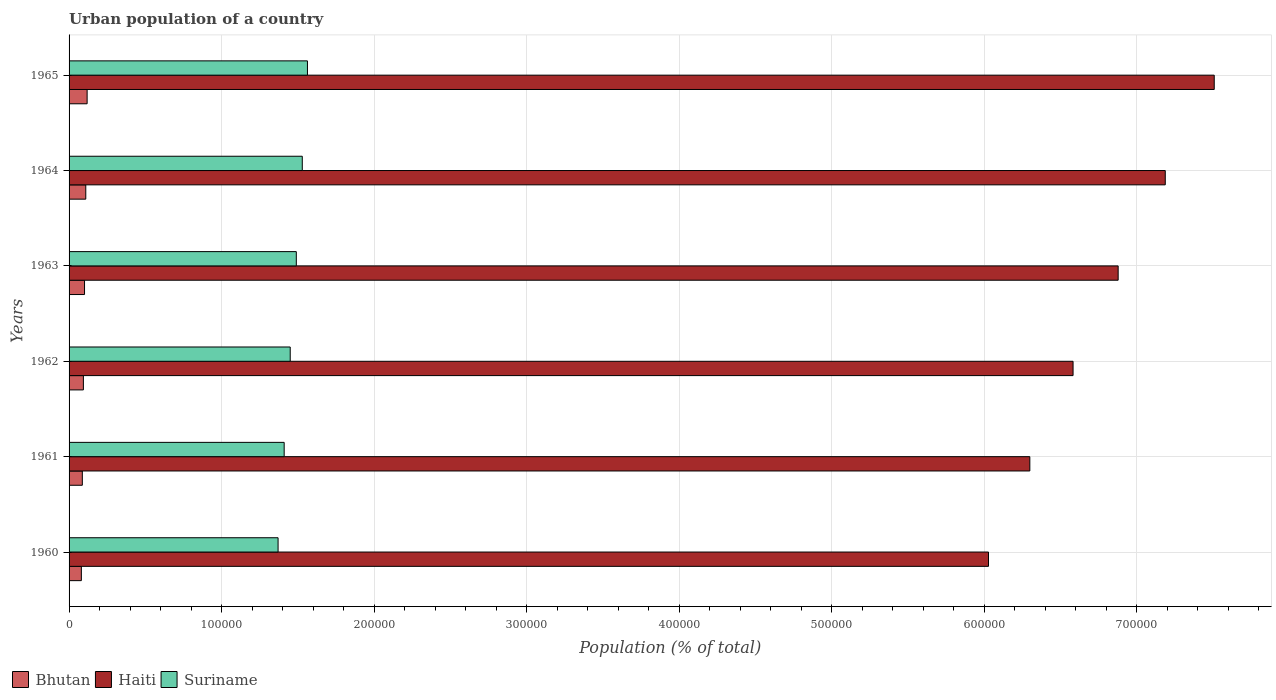How many different coloured bars are there?
Ensure brevity in your answer.  3. Are the number of bars per tick equal to the number of legend labels?
Ensure brevity in your answer.  Yes. How many bars are there on the 1st tick from the bottom?
Make the answer very short. 3. In how many cases, is the number of bars for a given year not equal to the number of legend labels?
Your response must be concise. 0. What is the urban population in Suriname in 1965?
Your answer should be compact. 1.56e+05. Across all years, what is the maximum urban population in Bhutan?
Ensure brevity in your answer.  1.18e+04. Across all years, what is the minimum urban population in Suriname?
Make the answer very short. 1.37e+05. In which year was the urban population in Bhutan maximum?
Offer a terse response. 1965. What is the total urban population in Suriname in the graph?
Ensure brevity in your answer.  8.81e+05. What is the difference between the urban population in Suriname in 1963 and that in 1964?
Give a very brief answer. -3910. What is the difference between the urban population in Suriname in 1965 and the urban population in Bhutan in 1960?
Make the answer very short. 1.48e+05. What is the average urban population in Bhutan per year?
Your response must be concise. 9844.83. In the year 1962, what is the difference between the urban population in Bhutan and urban population in Suriname?
Provide a short and direct response. -1.36e+05. In how many years, is the urban population in Bhutan greater than 760000 %?
Keep it short and to the point. 0. What is the ratio of the urban population in Haiti in 1960 to that in 1962?
Provide a succinct answer. 0.92. Is the difference between the urban population in Bhutan in 1962 and 1964 greater than the difference between the urban population in Suriname in 1962 and 1964?
Ensure brevity in your answer.  Yes. What is the difference between the highest and the second highest urban population in Haiti?
Provide a succinct answer. 3.21e+04. What is the difference between the highest and the lowest urban population in Suriname?
Provide a short and direct response. 1.93e+04. In how many years, is the urban population in Haiti greater than the average urban population in Haiti taken over all years?
Your answer should be compact. 3. What does the 1st bar from the top in 1965 represents?
Keep it short and to the point. Suriname. What does the 2nd bar from the bottom in 1962 represents?
Keep it short and to the point. Haiti. Is it the case that in every year, the sum of the urban population in Haiti and urban population in Suriname is greater than the urban population in Bhutan?
Give a very brief answer. Yes. How many bars are there?
Your response must be concise. 18. Are all the bars in the graph horizontal?
Ensure brevity in your answer.  Yes. Are the values on the major ticks of X-axis written in scientific E-notation?
Your answer should be very brief. No. Does the graph contain any zero values?
Make the answer very short. No. How many legend labels are there?
Offer a terse response. 3. What is the title of the graph?
Provide a succinct answer. Urban population of a country. What is the label or title of the X-axis?
Ensure brevity in your answer.  Population (% of total). What is the Population (% of total) in Bhutan in 1960?
Give a very brief answer. 8059. What is the Population (% of total) in Haiti in 1960?
Your answer should be very brief. 6.03e+05. What is the Population (% of total) of Suriname in 1960?
Offer a terse response. 1.37e+05. What is the Population (% of total) in Bhutan in 1961?
Your answer should be compact. 8695. What is the Population (% of total) of Haiti in 1961?
Ensure brevity in your answer.  6.30e+05. What is the Population (% of total) of Suriname in 1961?
Provide a short and direct response. 1.41e+05. What is the Population (% of total) in Bhutan in 1962?
Your response must be concise. 9386. What is the Population (% of total) in Haiti in 1962?
Your answer should be compact. 6.58e+05. What is the Population (% of total) in Suriname in 1962?
Your answer should be very brief. 1.45e+05. What is the Population (% of total) in Bhutan in 1963?
Your response must be concise. 1.01e+04. What is the Population (% of total) in Haiti in 1963?
Offer a terse response. 6.88e+05. What is the Population (% of total) in Suriname in 1963?
Offer a terse response. 1.49e+05. What is the Population (% of total) in Bhutan in 1964?
Make the answer very short. 1.10e+04. What is the Population (% of total) in Haiti in 1964?
Your answer should be compact. 7.19e+05. What is the Population (% of total) in Suriname in 1964?
Ensure brevity in your answer.  1.53e+05. What is the Population (% of total) of Bhutan in 1965?
Ensure brevity in your answer.  1.18e+04. What is the Population (% of total) in Haiti in 1965?
Your response must be concise. 7.51e+05. What is the Population (% of total) of Suriname in 1965?
Provide a short and direct response. 1.56e+05. Across all years, what is the maximum Population (% of total) of Bhutan?
Offer a very short reply. 1.18e+04. Across all years, what is the maximum Population (% of total) of Haiti?
Provide a short and direct response. 7.51e+05. Across all years, what is the maximum Population (% of total) of Suriname?
Your answer should be compact. 1.56e+05. Across all years, what is the minimum Population (% of total) of Bhutan?
Make the answer very short. 8059. Across all years, what is the minimum Population (% of total) of Haiti?
Offer a terse response. 6.03e+05. Across all years, what is the minimum Population (% of total) of Suriname?
Keep it short and to the point. 1.37e+05. What is the total Population (% of total) of Bhutan in the graph?
Keep it short and to the point. 5.91e+04. What is the total Population (% of total) of Haiti in the graph?
Provide a succinct answer. 4.05e+06. What is the total Population (% of total) in Suriname in the graph?
Make the answer very short. 8.81e+05. What is the difference between the Population (% of total) of Bhutan in 1960 and that in 1961?
Your answer should be very brief. -636. What is the difference between the Population (% of total) in Haiti in 1960 and that in 1961?
Give a very brief answer. -2.71e+04. What is the difference between the Population (% of total) of Suriname in 1960 and that in 1961?
Give a very brief answer. -3994. What is the difference between the Population (% of total) of Bhutan in 1960 and that in 1962?
Provide a short and direct response. -1327. What is the difference between the Population (% of total) of Haiti in 1960 and that in 1962?
Provide a succinct answer. -5.54e+04. What is the difference between the Population (% of total) of Suriname in 1960 and that in 1962?
Make the answer very short. -7960. What is the difference between the Population (% of total) in Bhutan in 1960 and that in 1963?
Keep it short and to the point. -2077. What is the difference between the Population (% of total) of Haiti in 1960 and that in 1963?
Provide a succinct answer. -8.50e+04. What is the difference between the Population (% of total) of Suriname in 1960 and that in 1963?
Your answer should be very brief. -1.20e+04. What is the difference between the Population (% of total) in Bhutan in 1960 and that in 1964?
Offer a terse response. -2893. What is the difference between the Population (% of total) of Haiti in 1960 and that in 1964?
Provide a succinct answer. -1.16e+05. What is the difference between the Population (% of total) in Suriname in 1960 and that in 1964?
Make the answer very short. -1.59e+04. What is the difference between the Population (% of total) in Bhutan in 1960 and that in 1965?
Provide a succinct answer. -3782. What is the difference between the Population (% of total) in Haiti in 1960 and that in 1965?
Offer a terse response. -1.48e+05. What is the difference between the Population (% of total) in Suriname in 1960 and that in 1965?
Give a very brief answer. -1.93e+04. What is the difference between the Population (% of total) in Bhutan in 1961 and that in 1962?
Your response must be concise. -691. What is the difference between the Population (% of total) in Haiti in 1961 and that in 1962?
Your response must be concise. -2.83e+04. What is the difference between the Population (% of total) of Suriname in 1961 and that in 1962?
Offer a very short reply. -3966. What is the difference between the Population (% of total) in Bhutan in 1961 and that in 1963?
Make the answer very short. -1441. What is the difference between the Population (% of total) in Haiti in 1961 and that in 1963?
Offer a terse response. -5.79e+04. What is the difference between the Population (% of total) of Suriname in 1961 and that in 1963?
Make the answer very short. -7964. What is the difference between the Population (% of total) in Bhutan in 1961 and that in 1964?
Keep it short and to the point. -2257. What is the difference between the Population (% of total) of Haiti in 1961 and that in 1964?
Make the answer very short. -8.88e+04. What is the difference between the Population (% of total) of Suriname in 1961 and that in 1964?
Offer a very short reply. -1.19e+04. What is the difference between the Population (% of total) in Bhutan in 1961 and that in 1965?
Provide a succinct answer. -3146. What is the difference between the Population (% of total) in Haiti in 1961 and that in 1965?
Offer a terse response. -1.21e+05. What is the difference between the Population (% of total) in Suriname in 1961 and that in 1965?
Your answer should be compact. -1.53e+04. What is the difference between the Population (% of total) in Bhutan in 1962 and that in 1963?
Provide a short and direct response. -750. What is the difference between the Population (% of total) of Haiti in 1962 and that in 1963?
Keep it short and to the point. -2.96e+04. What is the difference between the Population (% of total) in Suriname in 1962 and that in 1963?
Provide a short and direct response. -3998. What is the difference between the Population (% of total) in Bhutan in 1962 and that in 1964?
Offer a very short reply. -1566. What is the difference between the Population (% of total) in Haiti in 1962 and that in 1964?
Give a very brief answer. -6.05e+04. What is the difference between the Population (% of total) in Suriname in 1962 and that in 1964?
Ensure brevity in your answer.  -7908. What is the difference between the Population (% of total) in Bhutan in 1962 and that in 1965?
Your response must be concise. -2455. What is the difference between the Population (% of total) of Haiti in 1962 and that in 1965?
Provide a short and direct response. -9.26e+04. What is the difference between the Population (% of total) of Suriname in 1962 and that in 1965?
Give a very brief answer. -1.13e+04. What is the difference between the Population (% of total) of Bhutan in 1963 and that in 1964?
Keep it short and to the point. -816. What is the difference between the Population (% of total) in Haiti in 1963 and that in 1964?
Your answer should be compact. -3.09e+04. What is the difference between the Population (% of total) of Suriname in 1963 and that in 1964?
Your response must be concise. -3910. What is the difference between the Population (% of total) of Bhutan in 1963 and that in 1965?
Offer a terse response. -1705. What is the difference between the Population (% of total) in Haiti in 1963 and that in 1965?
Offer a very short reply. -6.30e+04. What is the difference between the Population (% of total) in Suriname in 1963 and that in 1965?
Give a very brief answer. -7308. What is the difference between the Population (% of total) of Bhutan in 1964 and that in 1965?
Offer a very short reply. -889. What is the difference between the Population (% of total) in Haiti in 1964 and that in 1965?
Ensure brevity in your answer.  -3.21e+04. What is the difference between the Population (% of total) of Suriname in 1964 and that in 1965?
Give a very brief answer. -3398. What is the difference between the Population (% of total) of Bhutan in 1960 and the Population (% of total) of Haiti in 1961?
Keep it short and to the point. -6.22e+05. What is the difference between the Population (% of total) in Bhutan in 1960 and the Population (% of total) in Suriname in 1961?
Offer a terse response. -1.33e+05. What is the difference between the Population (% of total) in Haiti in 1960 and the Population (% of total) in Suriname in 1961?
Offer a terse response. 4.62e+05. What is the difference between the Population (% of total) in Bhutan in 1960 and the Population (% of total) in Haiti in 1962?
Your answer should be very brief. -6.50e+05. What is the difference between the Population (% of total) in Bhutan in 1960 and the Population (% of total) in Suriname in 1962?
Ensure brevity in your answer.  -1.37e+05. What is the difference between the Population (% of total) in Haiti in 1960 and the Population (% of total) in Suriname in 1962?
Your response must be concise. 4.58e+05. What is the difference between the Population (% of total) in Bhutan in 1960 and the Population (% of total) in Haiti in 1963?
Provide a succinct answer. -6.80e+05. What is the difference between the Population (% of total) in Bhutan in 1960 and the Population (% of total) in Suriname in 1963?
Offer a terse response. -1.41e+05. What is the difference between the Population (% of total) in Haiti in 1960 and the Population (% of total) in Suriname in 1963?
Make the answer very short. 4.54e+05. What is the difference between the Population (% of total) of Bhutan in 1960 and the Population (% of total) of Haiti in 1964?
Offer a very short reply. -7.11e+05. What is the difference between the Population (% of total) in Bhutan in 1960 and the Population (% of total) in Suriname in 1964?
Provide a short and direct response. -1.45e+05. What is the difference between the Population (% of total) in Haiti in 1960 and the Population (% of total) in Suriname in 1964?
Offer a very short reply. 4.50e+05. What is the difference between the Population (% of total) in Bhutan in 1960 and the Population (% of total) in Haiti in 1965?
Give a very brief answer. -7.43e+05. What is the difference between the Population (% of total) of Bhutan in 1960 and the Population (% of total) of Suriname in 1965?
Your answer should be very brief. -1.48e+05. What is the difference between the Population (% of total) in Haiti in 1960 and the Population (% of total) in Suriname in 1965?
Provide a succinct answer. 4.47e+05. What is the difference between the Population (% of total) in Bhutan in 1961 and the Population (% of total) in Haiti in 1962?
Your answer should be compact. -6.50e+05. What is the difference between the Population (% of total) in Bhutan in 1961 and the Population (% of total) in Suriname in 1962?
Provide a succinct answer. -1.36e+05. What is the difference between the Population (% of total) of Haiti in 1961 and the Population (% of total) of Suriname in 1962?
Your answer should be very brief. 4.85e+05. What is the difference between the Population (% of total) of Bhutan in 1961 and the Population (% of total) of Haiti in 1963?
Make the answer very short. -6.79e+05. What is the difference between the Population (% of total) in Bhutan in 1961 and the Population (% of total) in Suriname in 1963?
Ensure brevity in your answer.  -1.40e+05. What is the difference between the Population (% of total) in Haiti in 1961 and the Population (% of total) in Suriname in 1963?
Give a very brief answer. 4.81e+05. What is the difference between the Population (% of total) of Bhutan in 1961 and the Population (% of total) of Haiti in 1964?
Make the answer very short. -7.10e+05. What is the difference between the Population (% of total) in Bhutan in 1961 and the Population (% of total) in Suriname in 1964?
Make the answer very short. -1.44e+05. What is the difference between the Population (% of total) in Haiti in 1961 and the Population (% of total) in Suriname in 1964?
Offer a very short reply. 4.77e+05. What is the difference between the Population (% of total) in Bhutan in 1961 and the Population (% of total) in Haiti in 1965?
Make the answer very short. -7.42e+05. What is the difference between the Population (% of total) in Bhutan in 1961 and the Population (% of total) in Suriname in 1965?
Offer a very short reply. -1.48e+05. What is the difference between the Population (% of total) in Haiti in 1961 and the Population (% of total) in Suriname in 1965?
Provide a short and direct response. 4.74e+05. What is the difference between the Population (% of total) of Bhutan in 1962 and the Population (% of total) of Haiti in 1963?
Provide a short and direct response. -6.78e+05. What is the difference between the Population (% of total) of Bhutan in 1962 and the Population (% of total) of Suriname in 1963?
Make the answer very short. -1.40e+05. What is the difference between the Population (% of total) in Haiti in 1962 and the Population (% of total) in Suriname in 1963?
Ensure brevity in your answer.  5.09e+05. What is the difference between the Population (% of total) of Bhutan in 1962 and the Population (% of total) of Haiti in 1964?
Keep it short and to the point. -7.09e+05. What is the difference between the Population (% of total) in Bhutan in 1962 and the Population (% of total) in Suriname in 1964?
Keep it short and to the point. -1.44e+05. What is the difference between the Population (% of total) of Haiti in 1962 and the Population (% of total) of Suriname in 1964?
Keep it short and to the point. 5.05e+05. What is the difference between the Population (% of total) in Bhutan in 1962 and the Population (% of total) in Haiti in 1965?
Keep it short and to the point. -7.41e+05. What is the difference between the Population (% of total) of Bhutan in 1962 and the Population (% of total) of Suriname in 1965?
Offer a very short reply. -1.47e+05. What is the difference between the Population (% of total) in Haiti in 1962 and the Population (% of total) in Suriname in 1965?
Ensure brevity in your answer.  5.02e+05. What is the difference between the Population (% of total) of Bhutan in 1963 and the Population (% of total) of Haiti in 1964?
Give a very brief answer. -7.09e+05. What is the difference between the Population (% of total) in Bhutan in 1963 and the Population (% of total) in Suriname in 1964?
Make the answer very short. -1.43e+05. What is the difference between the Population (% of total) of Haiti in 1963 and the Population (% of total) of Suriname in 1964?
Provide a succinct answer. 5.35e+05. What is the difference between the Population (% of total) of Bhutan in 1963 and the Population (% of total) of Haiti in 1965?
Your answer should be very brief. -7.41e+05. What is the difference between the Population (% of total) of Bhutan in 1963 and the Population (% of total) of Suriname in 1965?
Keep it short and to the point. -1.46e+05. What is the difference between the Population (% of total) of Haiti in 1963 and the Population (% of total) of Suriname in 1965?
Your response must be concise. 5.32e+05. What is the difference between the Population (% of total) in Bhutan in 1964 and the Population (% of total) in Haiti in 1965?
Your response must be concise. -7.40e+05. What is the difference between the Population (% of total) in Bhutan in 1964 and the Population (% of total) in Suriname in 1965?
Offer a very short reply. -1.45e+05. What is the difference between the Population (% of total) in Haiti in 1964 and the Population (% of total) in Suriname in 1965?
Give a very brief answer. 5.62e+05. What is the average Population (% of total) of Bhutan per year?
Your answer should be very brief. 9844.83. What is the average Population (% of total) of Haiti per year?
Ensure brevity in your answer.  6.75e+05. What is the average Population (% of total) in Suriname per year?
Make the answer very short. 1.47e+05. In the year 1960, what is the difference between the Population (% of total) of Bhutan and Population (% of total) of Haiti?
Provide a succinct answer. -5.95e+05. In the year 1960, what is the difference between the Population (% of total) of Bhutan and Population (% of total) of Suriname?
Your answer should be very brief. -1.29e+05. In the year 1960, what is the difference between the Population (% of total) of Haiti and Population (% of total) of Suriname?
Offer a very short reply. 4.66e+05. In the year 1961, what is the difference between the Population (% of total) in Bhutan and Population (% of total) in Haiti?
Your answer should be very brief. -6.21e+05. In the year 1961, what is the difference between the Population (% of total) in Bhutan and Population (% of total) in Suriname?
Your answer should be very brief. -1.32e+05. In the year 1961, what is the difference between the Population (% of total) of Haiti and Population (% of total) of Suriname?
Give a very brief answer. 4.89e+05. In the year 1962, what is the difference between the Population (% of total) in Bhutan and Population (% of total) in Haiti?
Your response must be concise. -6.49e+05. In the year 1962, what is the difference between the Population (% of total) of Bhutan and Population (% of total) of Suriname?
Your answer should be compact. -1.36e+05. In the year 1962, what is the difference between the Population (% of total) in Haiti and Population (% of total) in Suriname?
Provide a succinct answer. 5.13e+05. In the year 1963, what is the difference between the Population (% of total) of Bhutan and Population (% of total) of Haiti?
Your answer should be very brief. -6.78e+05. In the year 1963, what is the difference between the Population (% of total) of Bhutan and Population (% of total) of Suriname?
Keep it short and to the point. -1.39e+05. In the year 1963, what is the difference between the Population (% of total) in Haiti and Population (% of total) in Suriname?
Give a very brief answer. 5.39e+05. In the year 1964, what is the difference between the Population (% of total) of Bhutan and Population (% of total) of Haiti?
Keep it short and to the point. -7.08e+05. In the year 1964, what is the difference between the Population (% of total) in Bhutan and Population (% of total) in Suriname?
Ensure brevity in your answer.  -1.42e+05. In the year 1964, what is the difference between the Population (% of total) of Haiti and Population (% of total) of Suriname?
Your answer should be compact. 5.66e+05. In the year 1965, what is the difference between the Population (% of total) of Bhutan and Population (% of total) of Haiti?
Offer a very short reply. -7.39e+05. In the year 1965, what is the difference between the Population (% of total) in Bhutan and Population (% of total) in Suriname?
Your response must be concise. -1.44e+05. In the year 1965, what is the difference between the Population (% of total) of Haiti and Population (% of total) of Suriname?
Offer a terse response. 5.95e+05. What is the ratio of the Population (% of total) in Bhutan in 1960 to that in 1961?
Your answer should be very brief. 0.93. What is the ratio of the Population (% of total) of Suriname in 1960 to that in 1961?
Your answer should be compact. 0.97. What is the ratio of the Population (% of total) in Bhutan in 1960 to that in 1962?
Keep it short and to the point. 0.86. What is the ratio of the Population (% of total) of Haiti in 1960 to that in 1962?
Offer a terse response. 0.92. What is the ratio of the Population (% of total) in Suriname in 1960 to that in 1962?
Your answer should be compact. 0.95. What is the ratio of the Population (% of total) of Bhutan in 1960 to that in 1963?
Offer a terse response. 0.8. What is the ratio of the Population (% of total) of Haiti in 1960 to that in 1963?
Make the answer very short. 0.88. What is the ratio of the Population (% of total) of Suriname in 1960 to that in 1963?
Offer a terse response. 0.92. What is the ratio of the Population (% of total) of Bhutan in 1960 to that in 1964?
Your answer should be compact. 0.74. What is the ratio of the Population (% of total) of Haiti in 1960 to that in 1964?
Make the answer very short. 0.84. What is the ratio of the Population (% of total) in Suriname in 1960 to that in 1964?
Make the answer very short. 0.9. What is the ratio of the Population (% of total) in Bhutan in 1960 to that in 1965?
Make the answer very short. 0.68. What is the ratio of the Population (% of total) in Haiti in 1960 to that in 1965?
Ensure brevity in your answer.  0.8. What is the ratio of the Population (% of total) of Suriname in 1960 to that in 1965?
Provide a succinct answer. 0.88. What is the ratio of the Population (% of total) in Bhutan in 1961 to that in 1962?
Provide a short and direct response. 0.93. What is the ratio of the Population (% of total) in Haiti in 1961 to that in 1962?
Your response must be concise. 0.96. What is the ratio of the Population (% of total) in Suriname in 1961 to that in 1962?
Your answer should be very brief. 0.97. What is the ratio of the Population (% of total) in Bhutan in 1961 to that in 1963?
Keep it short and to the point. 0.86. What is the ratio of the Population (% of total) of Haiti in 1961 to that in 1963?
Make the answer very short. 0.92. What is the ratio of the Population (% of total) of Suriname in 1961 to that in 1963?
Offer a terse response. 0.95. What is the ratio of the Population (% of total) of Bhutan in 1961 to that in 1964?
Offer a terse response. 0.79. What is the ratio of the Population (% of total) in Haiti in 1961 to that in 1964?
Offer a very short reply. 0.88. What is the ratio of the Population (% of total) of Suriname in 1961 to that in 1964?
Give a very brief answer. 0.92. What is the ratio of the Population (% of total) of Bhutan in 1961 to that in 1965?
Offer a very short reply. 0.73. What is the ratio of the Population (% of total) in Haiti in 1961 to that in 1965?
Offer a terse response. 0.84. What is the ratio of the Population (% of total) in Suriname in 1961 to that in 1965?
Provide a short and direct response. 0.9. What is the ratio of the Population (% of total) of Bhutan in 1962 to that in 1963?
Make the answer very short. 0.93. What is the ratio of the Population (% of total) in Suriname in 1962 to that in 1963?
Your response must be concise. 0.97. What is the ratio of the Population (% of total) in Bhutan in 1962 to that in 1964?
Make the answer very short. 0.86. What is the ratio of the Population (% of total) in Haiti in 1962 to that in 1964?
Make the answer very short. 0.92. What is the ratio of the Population (% of total) in Suriname in 1962 to that in 1964?
Make the answer very short. 0.95. What is the ratio of the Population (% of total) in Bhutan in 1962 to that in 1965?
Make the answer very short. 0.79. What is the ratio of the Population (% of total) of Haiti in 1962 to that in 1965?
Offer a very short reply. 0.88. What is the ratio of the Population (% of total) in Suriname in 1962 to that in 1965?
Make the answer very short. 0.93. What is the ratio of the Population (% of total) of Bhutan in 1963 to that in 1964?
Give a very brief answer. 0.93. What is the ratio of the Population (% of total) of Suriname in 1963 to that in 1964?
Give a very brief answer. 0.97. What is the ratio of the Population (% of total) of Bhutan in 1963 to that in 1965?
Your answer should be very brief. 0.86. What is the ratio of the Population (% of total) in Haiti in 1963 to that in 1965?
Give a very brief answer. 0.92. What is the ratio of the Population (% of total) in Suriname in 1963 to that in 1965?
Keep it short and to the point. 0.95. What is the ratio of the Population (% of total) of Bhutan in 1964 to that in 1965?
Make the answer very short. 0.92. What is the ratio of the Population (% of total) of Haiti in 1964 to that in 1965?
Offer a very short reply. 0.96. What is the ratio of the Population (% of total) of Suriname in 1964 to that in 1965?
Make the answer very short. 0.98. What is the difference between the highest and the second highest Population (% of total) in Bhutan?
Keep it short and to the point. 889. What is the difference between the highest and the second highest Population (% of total) in Haiti?
Give a very brief answer. 3.21e+04. What is the difference between the highest and the second highest Population (% of total) of Suriname?
Keep it short and to the point. 3398. What is the difference between the highest and the lowest Population (% of total) of Bhutan?
Provide a short and direct response. 3782. What is the difference between the highest and the lowest Population (% of total) in Haiti?
Your answer should be very brief. 1.48e+05. What is the difference between the highest and the lowest Population (% of total) of Suriname?
Provide a succinct answer. 1.93e+04. 